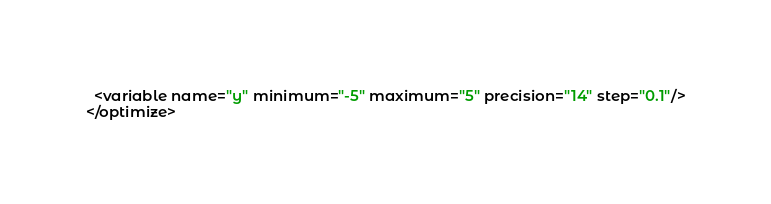<code> <loc_0><loc_0><loc_500><loc_500><_XML_>  <variable name="y" minimum="-5" maximum="5" precision="14" step="0.1"/>
</optimize>
</code> 